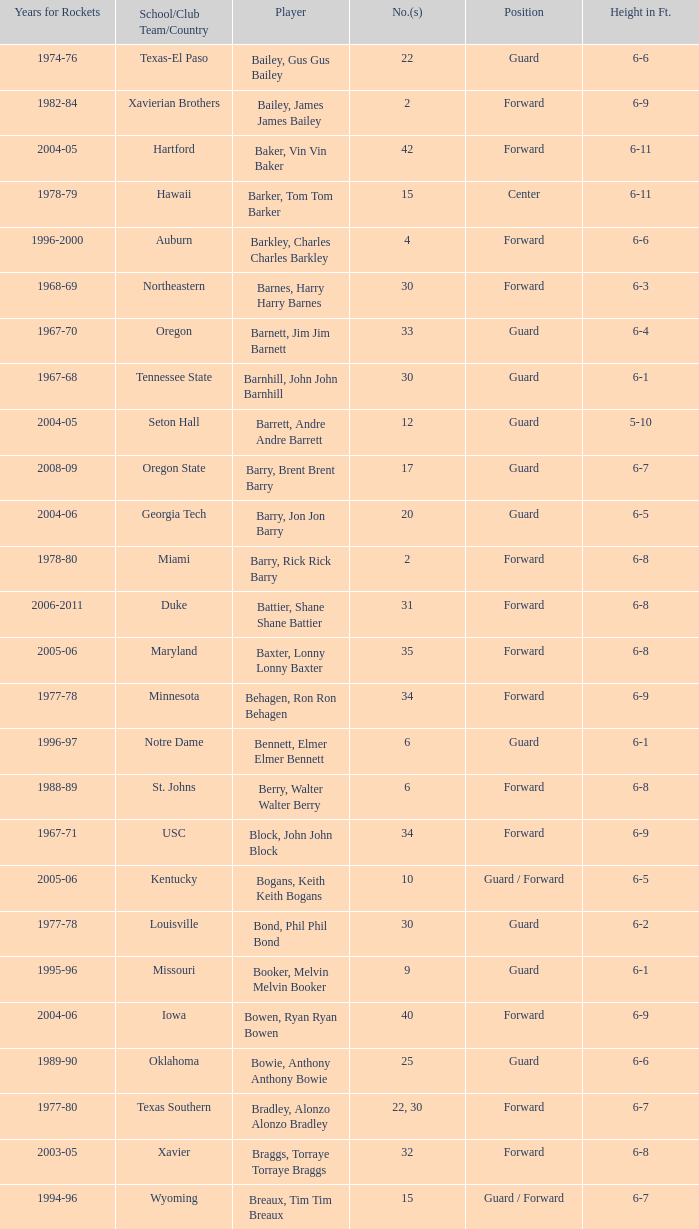What is the height of the player who attended Hartford? 6-11. 